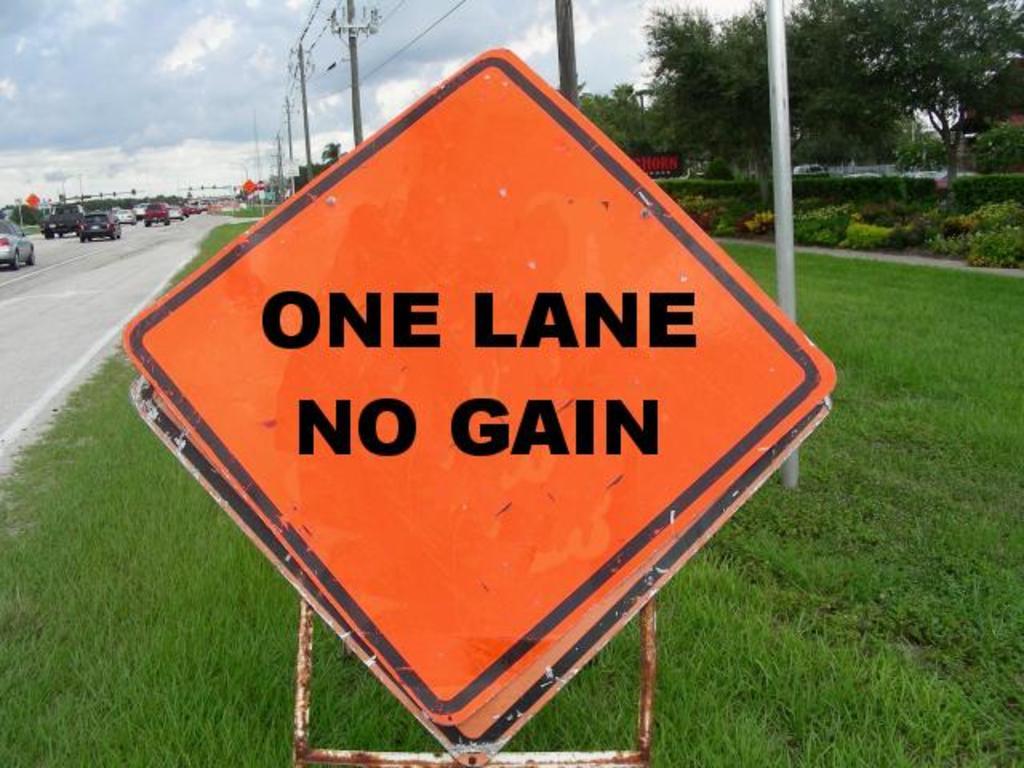Does the sign suggest there are more than one lane?
Make the answer very short. No. 